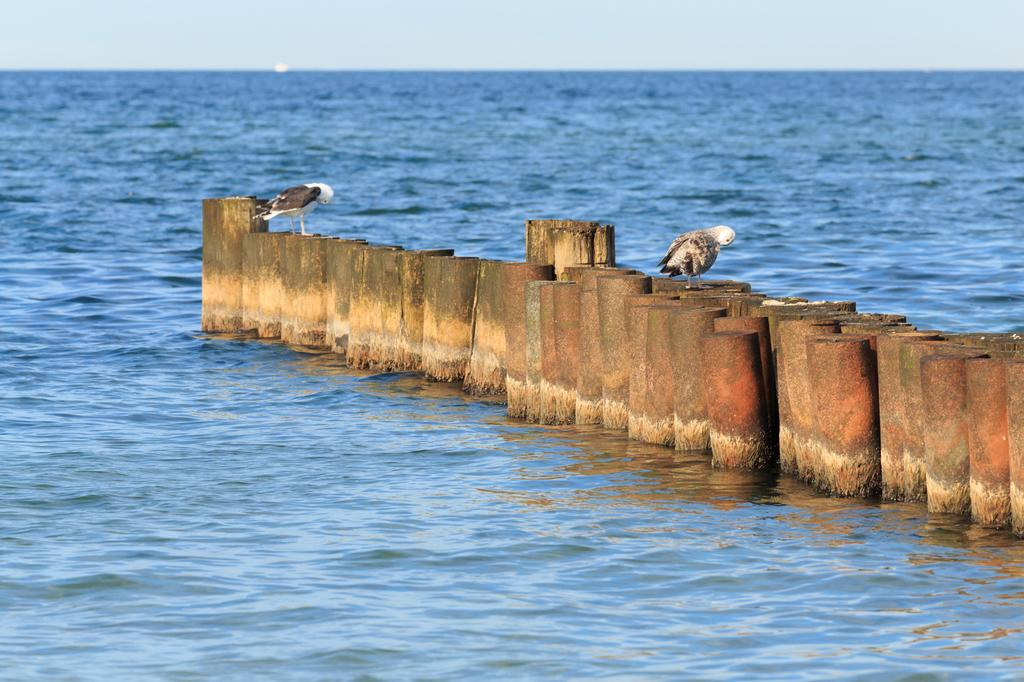What can be seen in the background of the image? The sky is visible in the background of the image. What is present in the foreground of the image? There is water visible in the image. What type of objects are in the image? There are wooden objects in the image. What animals are standing on the wooden objects? Birds are standing on the wooden objects. What color is the hair of the person in the image? There is no person present in the image, so there is no hair to describe. 